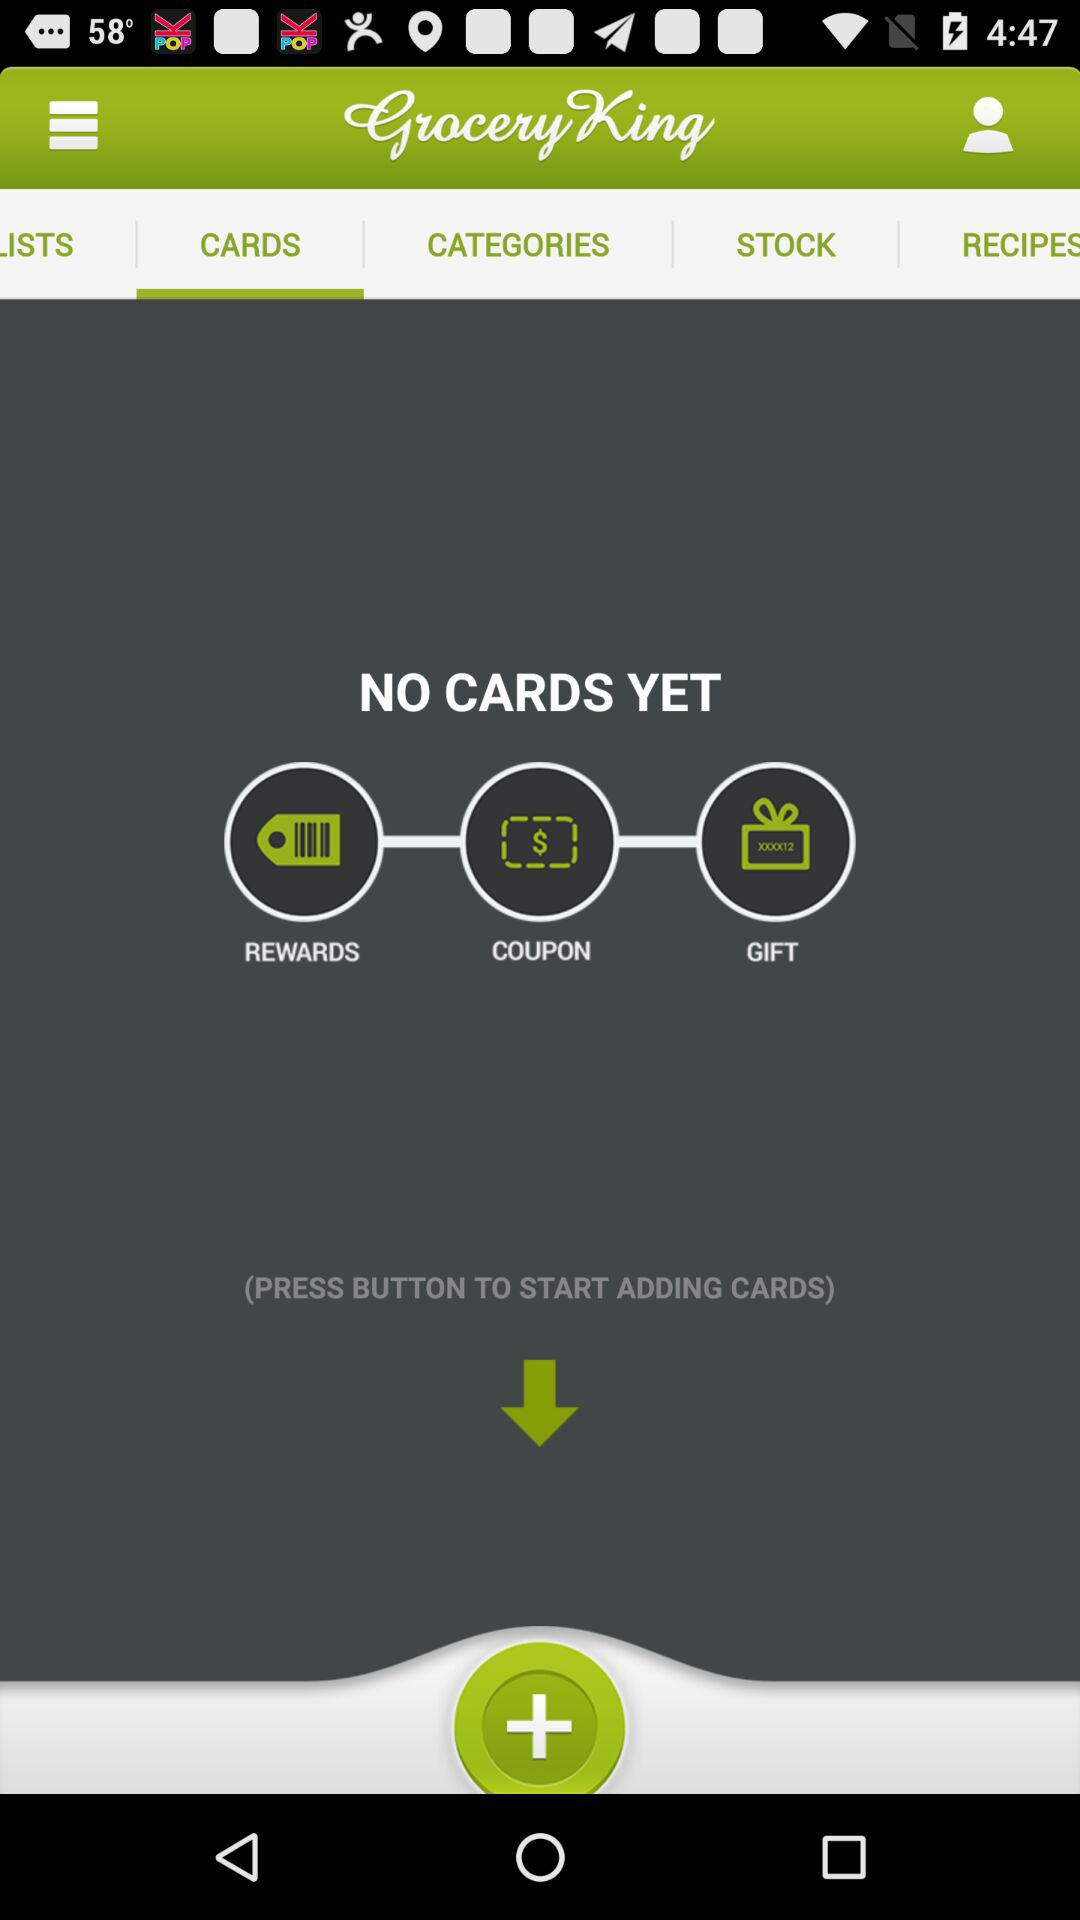How many notifications are there in "STOCKS"?
When the provided information is insufficient, respond with <no answer>. <no answer> 